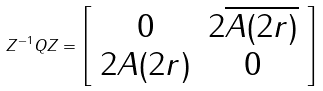Convert formula to latex. <formula><loc_0><loc_0><loc_500><loc_500>Z ^ { - 1 } Q Z = \left [ \begin{array} { c c } 0 & 2 \overline { A ( 2 r ) } \\ 2 A ( 2 r ) & 0 \end{array} \right ]</formula> 